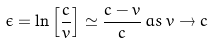<formula> <loc_0><loc_0><loc_500><loc_500>\epsilon = \ln \left [ \frac { c } { v } \right ] \simeq \frac { c - v } { c } \, a s \, v \to c</formula> 